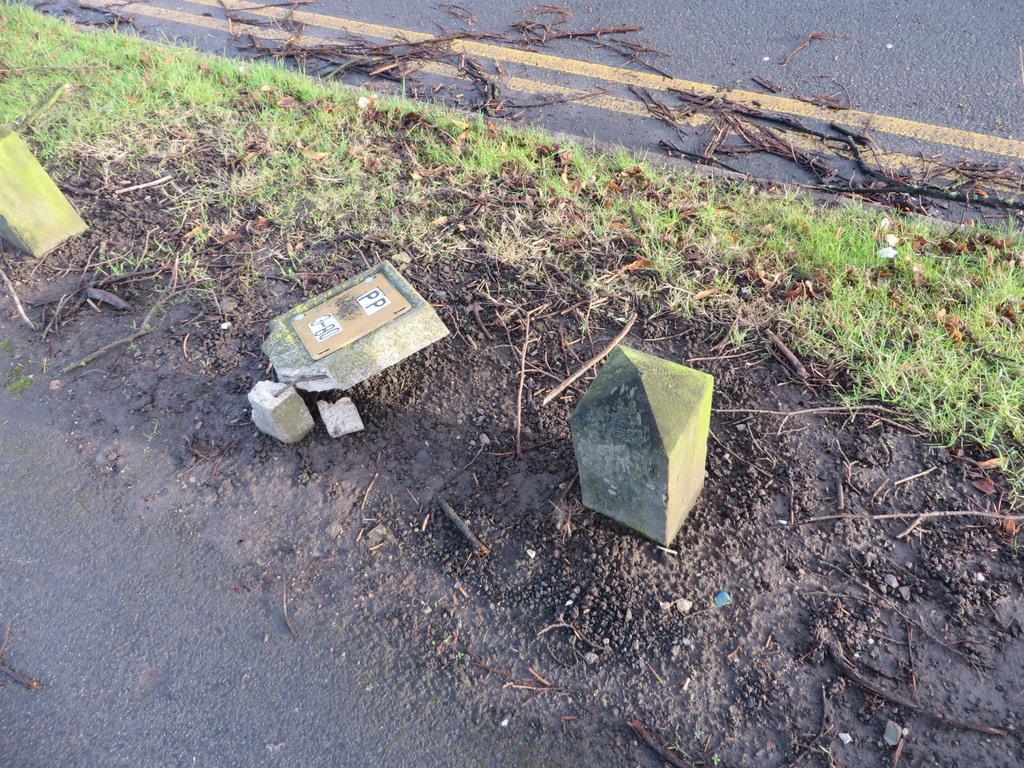Describe this image in one or two sentences. In this image we can see some barrier stones on the ground. We can also see some dried branches, grass and the pathway. 